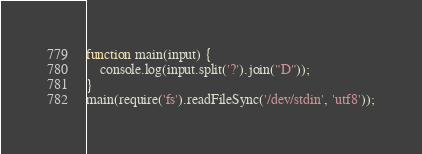<code> <loc_0><loc_0><loc_500><loc_500><_JavaScript_>function main(input) {
    console.log(input.split('?').join("D"));
}
main(require('fs').readFileSync('/dev/stdin', 'utf8'));</code> 